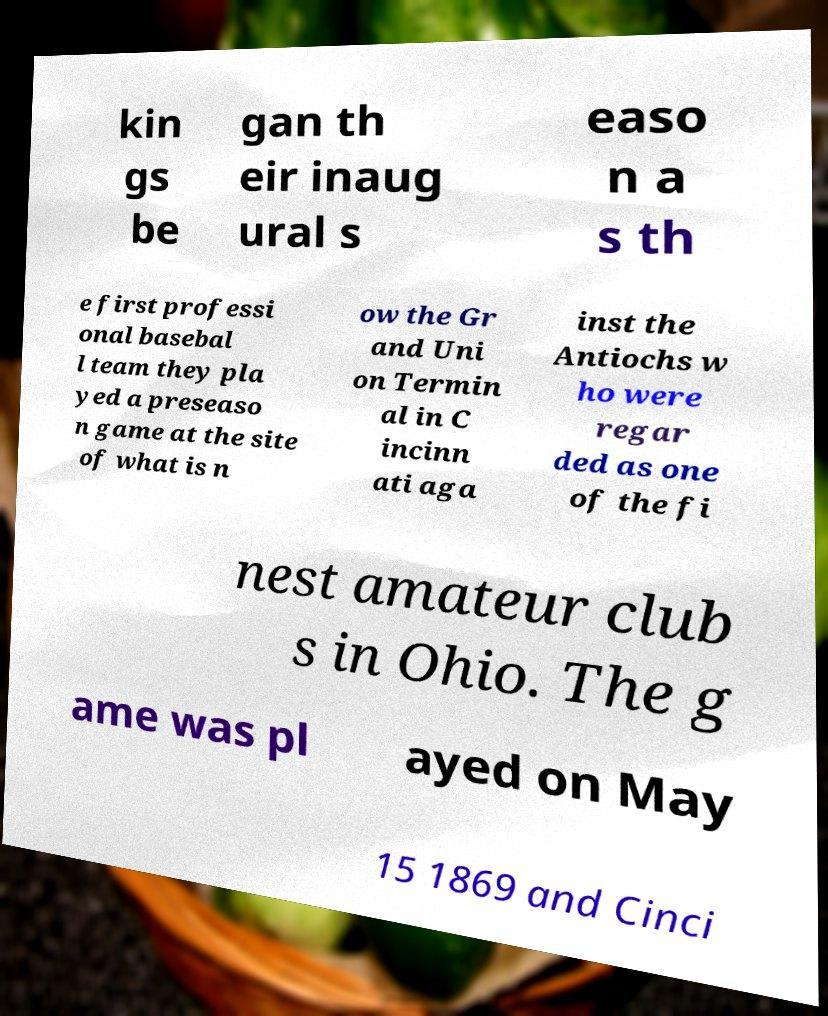There's text embedded in this image that I need extracted. Can you transcribe it verbatim? kin gs be gan th eir inaug ural s easo n a s th e first professi onal basebal l team they pla yed a preseaso n game at the site of what is n ow the Gr and Uni on Termin al in C incinn ati aga inst the Antiochs w ho were regar ded as one of the fi nest amateur club s in Ohio. The g ame was pl ayed on May 15 1869 and Cinci 